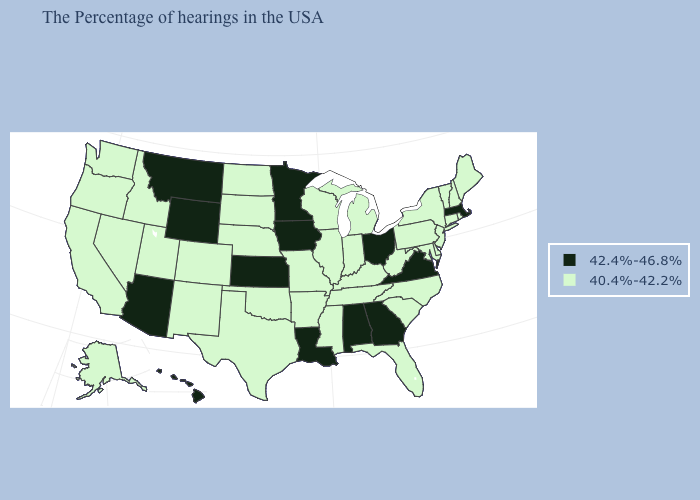What is the value of Maryland?
Answer briefly. 40.4%-42.2%. What is the lowest value in states that border Vermont?
Quick response, please. 40.4%-42.2%. Which states have the lowest value in the South?
Short answer required. Delaware, Maryland, North Carolina, South Carolina, West Virginia, Florida, Kentucky, Tennessee, Mississippi, Arkansas, Oklahoma, Texas. What is the lowest value in the USA?
Answer briefly. 40.4%-42.2%. What is the value of Alabama?
Keep it brief. 42.4%-46.8%. What is the value of Tennessee?
Keep it brief. 40.4%-42.2%. Does the map have missing data?
Be succinct. No. Name the states that have a value in the range 42.4%-46.8%?
Answer briefly. Massachusetts, Virginia, Ohio, Georgia, Alabama, Louisiana, Minnesota, Iowa, Kansas, Wyoming, Montana, Arizona, Hawaii. What is the value of Wyoming?
Give a very brief answer. 42.4%-46.8%. Name the states that have a value in the range 42.4%-46.8%?
Short answer required. Massachusetts, Virginia, Ohio, Georgia, Alabama, Louisiana, Minnesota, Iowa, Kansas, Wyoming, Montana, Arizona, Hawaii. Name the states that have a value in the range 42.4%-46.8%?
Answer briefly. Massachusetts, Virginia, Ohio, Georgia, Alabama, Louisiana, Minnesota, Iowa, Kansas, Wyoming, Montana, Arizona, Hawaii. What is the highest value in the Northeast ?
Quick response, please. 42.4%-46.8%. Name the states that have a value in the range 40.4%-42.2%?
Quick response, please. Maine, Rhode Island, New Hampshire, Vermont, Connecticut, New York, New Jersey, Delaware, Maryland, Pennsylvania, North Carolina, South Carolina, West Virginia, Florida, Michigan, Kentucky, Indiana, Tennessee, Wisconsin, Illinois, Mississippi, Missouri, Arkansas, Nebraska, Oklahoma, Texas, South Dakota, North Dakota, Colorado, New Mexico, Utah, Idaho, Nevada, California, Washington, Oregon, Alaska. What is the highest value in the USA?
Give a very brief answer. 42.4%-46.8%. Name the states that have a value in the range 40.4%-42.2%?
Answer briefly. Maine, Rhode Island, New Hampshire, Vermont, Connecticut, New York, New Jersey, Delaware, Maryland, Pennsylvania, North Carolina, South Carolina, West Virginia, Florida, Michigan, Kentucky, Indiana, Tennessee, Wisconsin, Illinois, Mississippi, Missouri, Arkansas, Nebraska, Oklahoma, Texas, South Dakota, North Dakota, Colorado, New Mexico, Utah, Idaho, Nevada, California, Washington, Oregon, Alaska. 